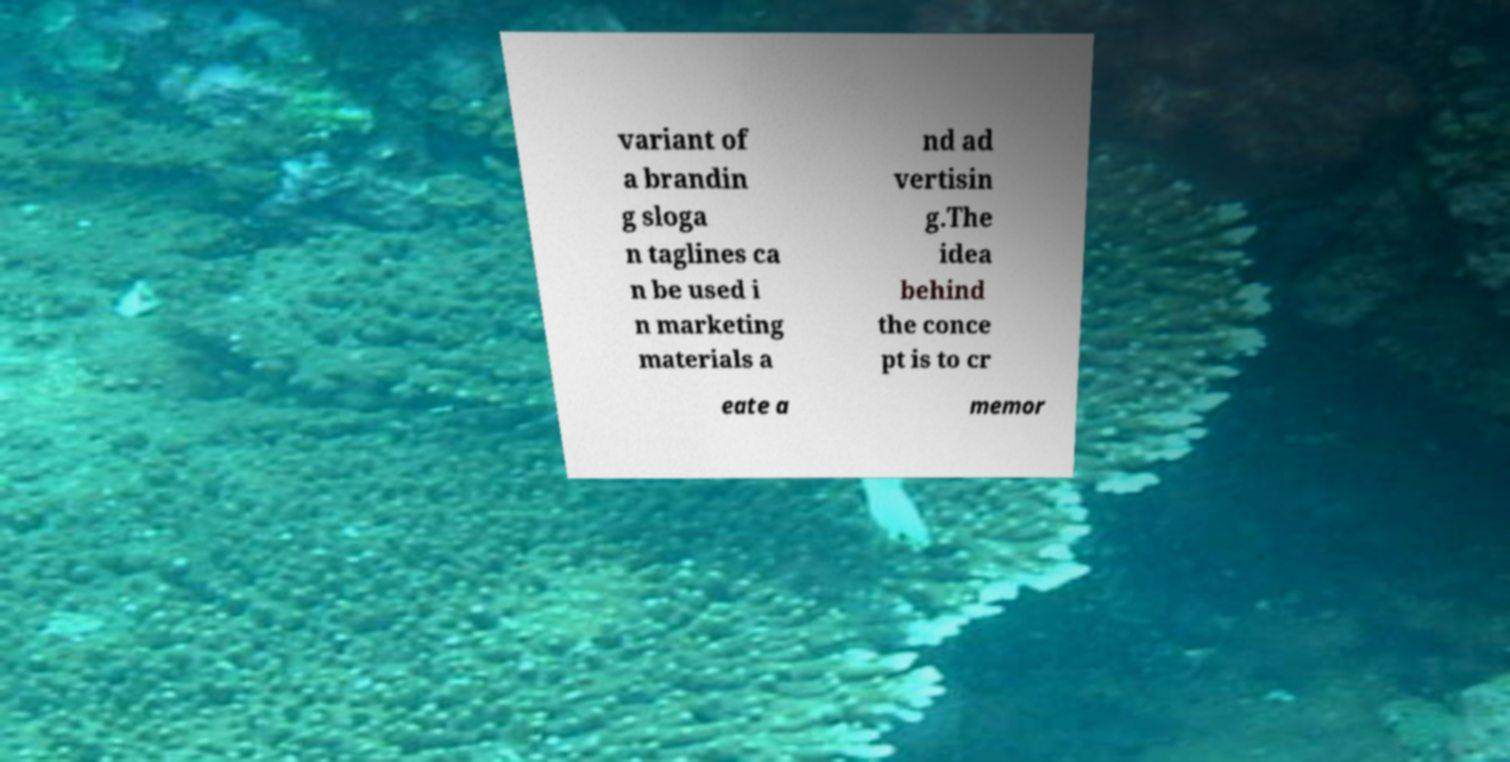What messages or text are displayed in this image? I need them in a readable, typed format. variant of a brandin g sloga n taglines ca n be used i n marketing materials a nd ad vertisin g.The idea behind the conce pt is to cr eate a memor 